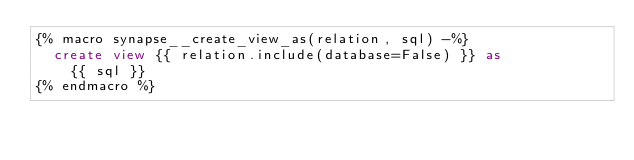Convert code to text. <code><loc_0><loc_0><loc_500><loc_500><_SQL_>{% macro synapse__create_view_as(relation, sql) -%}
  create view {{ relation.include(database=False) }} as
    {{ sql }}
{% endmacro %}</code> 